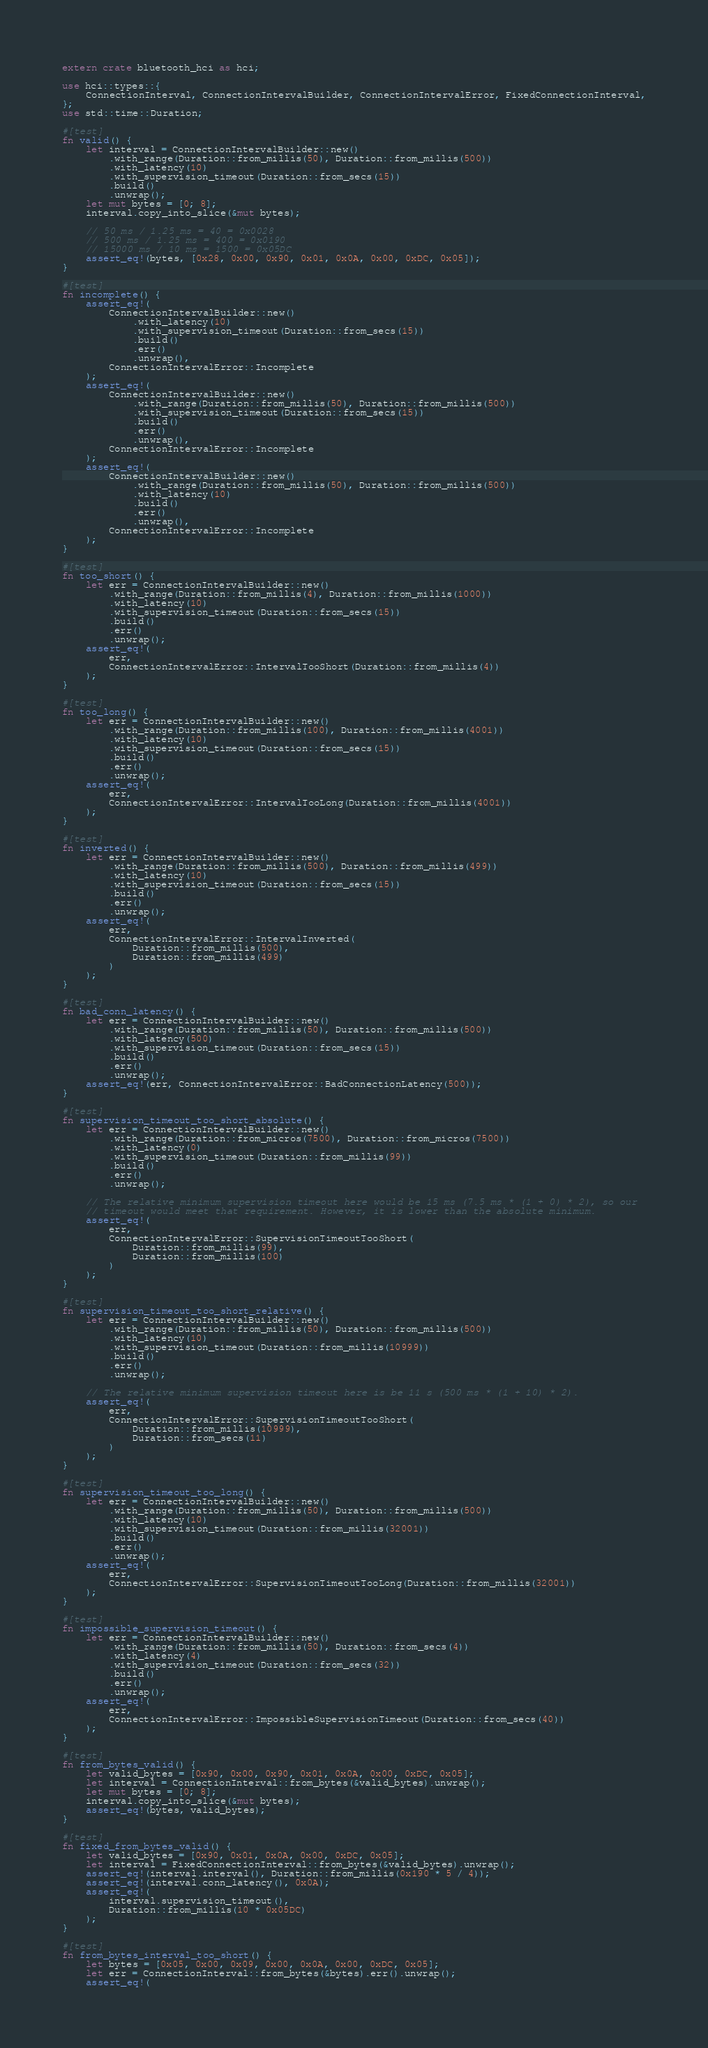Convert code to text. <code><loc_0><loc_0><loc_500><loc_500><_Rust_>extern crate bluetooth_hci as hci;

use hci::types::{
    ConnectionInterval, ConnectionIntervalBuilder, ConnectionIntervalError, FixedConnectionInterval,
};
use std::time::Duration;

#[test]
fn valid() {
    let interval = ConnectionIntervalBuilder::new()
        .with_range(Duration::from_millis(50), Duration::from_millis(500))
        .with_latency(10)
        .with_supervision_timeout(Duration::from_secs(15))
        .build()
        .unwrap();
    let mut bytes = [0; 8];
    interval.copy_into_slice(&mut bytes);

    // 50 ms / 1.25 ms = 40 = 0x0028
    // 500 ms / 1.25 ms = 400 = 0x0190
    // 15000 ms / 10 ms = 1500 = 0x05DC
    assert_eq!(bytes, [0x28, 0x00, 0x90, 0x01, 0x0A, 0x00, 0xDC, 0x05]);
}

#[test]
fn incomplete() {
    assert_eq!(
        ConnectionIntervalBuilder::new()
            .with_latency(10)
            .with_supervision_timeout(Duration::from_secs(15))
            .build()
            .err()
            .unwrap(),
        ConnectionIntervalError::Incomplete
    );
    assert_eq!(
        ConnectionIntervalBuilder::new()
            .with_range(Duration::from_millis(50), Duration::from_millis(500))
            .with_supervision_timeout(Duration::from_secs(15))
            .build()
            .err()
            .unwrap(),
        ConnectionIntervalError::Incomplete
    );
    assert_eq!(
        ConnectionIntervalBuilder::new()
            .with_range(Duration::from_millis(50), Duration::from_millis(500))
            .with_latency(10)
            .build()
            .err()
            .unwrap(),
        ConnectionIntervalError::Incomplete
    );
}

#[test]
fn too_short() {
    let err = ConnectionIntervalBuilder::new()
        .with_range(Duration::from_millis(4), Duration::from_millis(1000))
        .with_latency(10)
        .with_supervision_timeout(Duration::from_secs(15))
        .build()
        .err()
        .unwrap();
    assert_eq!(
        err,
        ConnectionIntervalError::IntervalTooShort(Duration::from_millis(4))
    );
}

#[test]
fn too_long() {
    let err = ConnectionIntervalBuilder::new()
        .with_range(Duration::from_millis(100), Duration::from_millis(4001))
        .with_latency(10)
        .with_supervision_timeout(Duration::from_secs(15))
        .build()
        .err()
        .unwrap();
    assert_eq!(
        err,
        ConnectionIntervalError::IntervalTooLong(Duration::from_millis(4001))
    );
}

#[test]
fn inverted() {
    let err = ConnectionIntervalBuilder::new()
        .with_range(Duration::from_millis(500), Duration::from_millis(499))
        .with_latency(10)
        .with_supervision_timeout(Duration::from_secs(15))
        .build()
        .err()
        .unwrap();
    assert_eq!(
        err,
        ConnectionIntervalError::IntervalInverted(
            Duration::from_millis(500),
            Duration::from_millis(499)
        )
    );
}

#[test]
fn bad_conn_latency() {
    let err = ConnectionIntervalBuilder::new()
        .with_range(Duration::from_millis(50), Duration::from_millis(500))
        .with_latency(500)
        .with_supervision_timeout(Duration::from_secs(15))
        .build()
        .err()
        .unwrap();
    assert_eq!(err, ConnectionIntervalError::BadConnectionLatency(500));
}

#[test]
fn supervision_timeout_too_short_absolute() {
    let err = ConnectionIntervalBuilder::new()
        .with_range(Duration::from_micros(7500), Duration::from_micros(7500))
        .with_latency(0)
        .with_supervision_timeout(Duration::from_millis(99))
        .build()
        .err()
        .unwrap();

    // The relative minimum supervision timeout here would be 15 ms (7.5 ms * (1 + 0) * 2), so our
    // timeout would meet that requirement. However, it is lower than the absolute minimum.
    assert_eq!(
        err,
        ConnectionIntervalError::SupervisionTimeoutTooShort(
            Duration::from_millis(99),
            Duration::from_millis(100)
        )
    );
}

#[test]
fn supervision_timeout_too_short_relative() {
    let err = ConnectionIntervalBuilder::new()
        .with_range(Duration::from_millis(50), Duration::from_millis(500))
        .with_latency(10)
        .with_supervision_timeout(Duration::from_millis(10999))
        .build()
        .err()
        .unwrap();

    // The relative minimum supervision timeout here is be 11 s (500 ms * (1 + 10) * 2).
    assert_eq!(
        err,
        ConnectionIntervalError::SupervisionTimeoutTooShort(
            Duration::from_millis(10999),
            Duration::from_secs(11)
        )
    );
}

#[test]
fn supervision_timeout_too_long() {
    let err = ConnectionIntervalBuilder::new()
        .with_range(Duration::from_millis(50), Duration::from_millis(500))
        .with_latency(10)
        .with_supervision_timeout(Duration::from_millis(32001))
        .build()
        .err()
        .unwrap();
    assert_eq!(
        err,
        ConnectionIntervalError::SupervisionTimeoutTooLong(Duration::from_millis(32001))
    );
}

#[test]
fn impossible_supervision_timeout() {
    let err = ConnectionIntervalBuilder::new()
        .with_range(Duration::from_millis(50), Duration::from_secs(4))
        .with_latency(4)
        .with_supervision_timeout(Duration::from_secs(32))
        .build()
        .err()
        .unwrap();
    assert_eq!(
        err,
        ConnectionIntervalError::ImpossibleSupervisionTimeout(Duration::from_secs(40))
    );
}

#[test]
fn from_bytes_valid() {
    let valid_bytes = [0x90, 0x00, 0x90, 0x01, 0x0A, 0x00, 0xDC, 0x05];
    let interval = ConnectionInterval::from_bytes(&valid_bytes).unwrap();
    let mut bytes = [0; 8];
    interval.copy_into_slice(&mut bytes);
    assert_eq!(bytes, valid_bytes);
}

#[test]
fn fixed_from_bytes_valid() {
    let valid_bytes = [0x90, 0x01, 0x0A, 0x00, 0xDC, 0x05];
    let interval = FixedConnectionInterval::from_bytes(&valid_bytes).unwrap();
    assert_eq!(interval.interval(), Duration::from_millis(0x190 * 5 / 4));
    assert_eq!(interval.conn_latency(), 0x0A);
    assert_eq!(
        interval.supervision_timeout(),
        Duration::from_millis(10 * 0x05DC)
    );
}

#[test]
fn from_bytes_interval_too_short() {
    let bytes = [0x05, 0x00, 0x09, 0x00, 0x0A, 0x00, 0xDC, 0x05];
    let err = ConnectionInterval::from_bytes(&bytes).err().unwrap();
    assert_eq!(</code> 